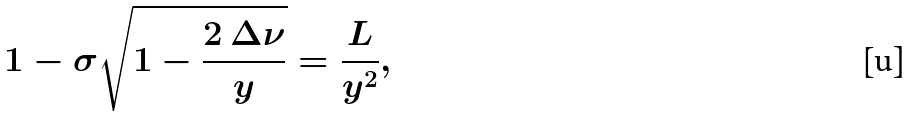<formula> <loc_0><loc_0><loc_500><loc_500>1 - \sigma \sqrt { 1 - \frac { 2 \, \Delta \nu } { y } } = \frac { L } { y ^ { 2 } } ,</formula> 